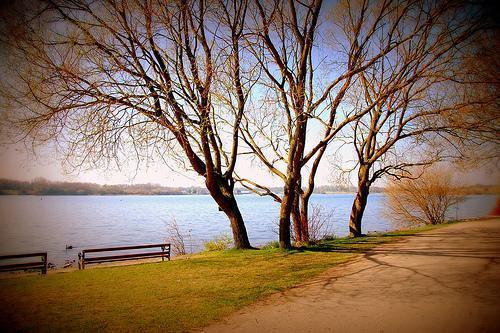How many branches can be seen?
Give a very brief answer. 2. 